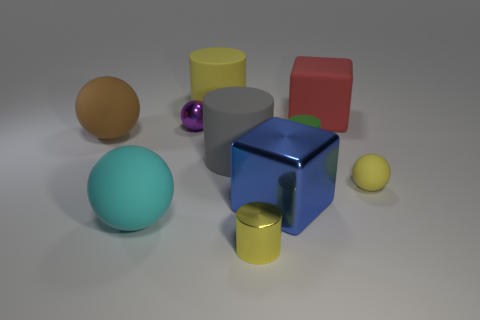Subtract all large yellow cylinders. How many cylinders are left? 3 Subtract all brown blocks. How many yellow cylinders are left? 2 Subtract all purple balls. How many balls are left? 3 Subtract all balls. How many objects are left? 6 Subtract all big red matte things. Subtract all green things. How many objects are left? 8 Add 7 large gray rubber objects. How many large gray rubber objects are left? 8 Add 10 yellow rubber blocks. How many yellow rubber blocks exist? 10 Subtract 1 yellow spheres. How many objects are left? 9 Subtract all red cylinders. Subtract all green blocks. How many cylinders are left? 4 